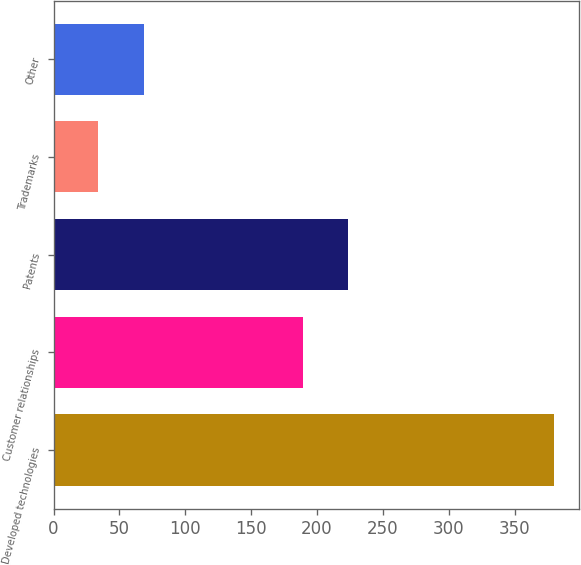Convert chart to OTSL. <chart><loc_0><loc_0><loc_500><loc_500><bar_chart><fcel>Developed technologies<fcel>Customer relationships<fcel>Patents<fcel>Trademarks<fcel>Other<nl><fcel>380<fcel>189<fcel>223.6<fcel>34<fcel>68.6<nl></chart> 